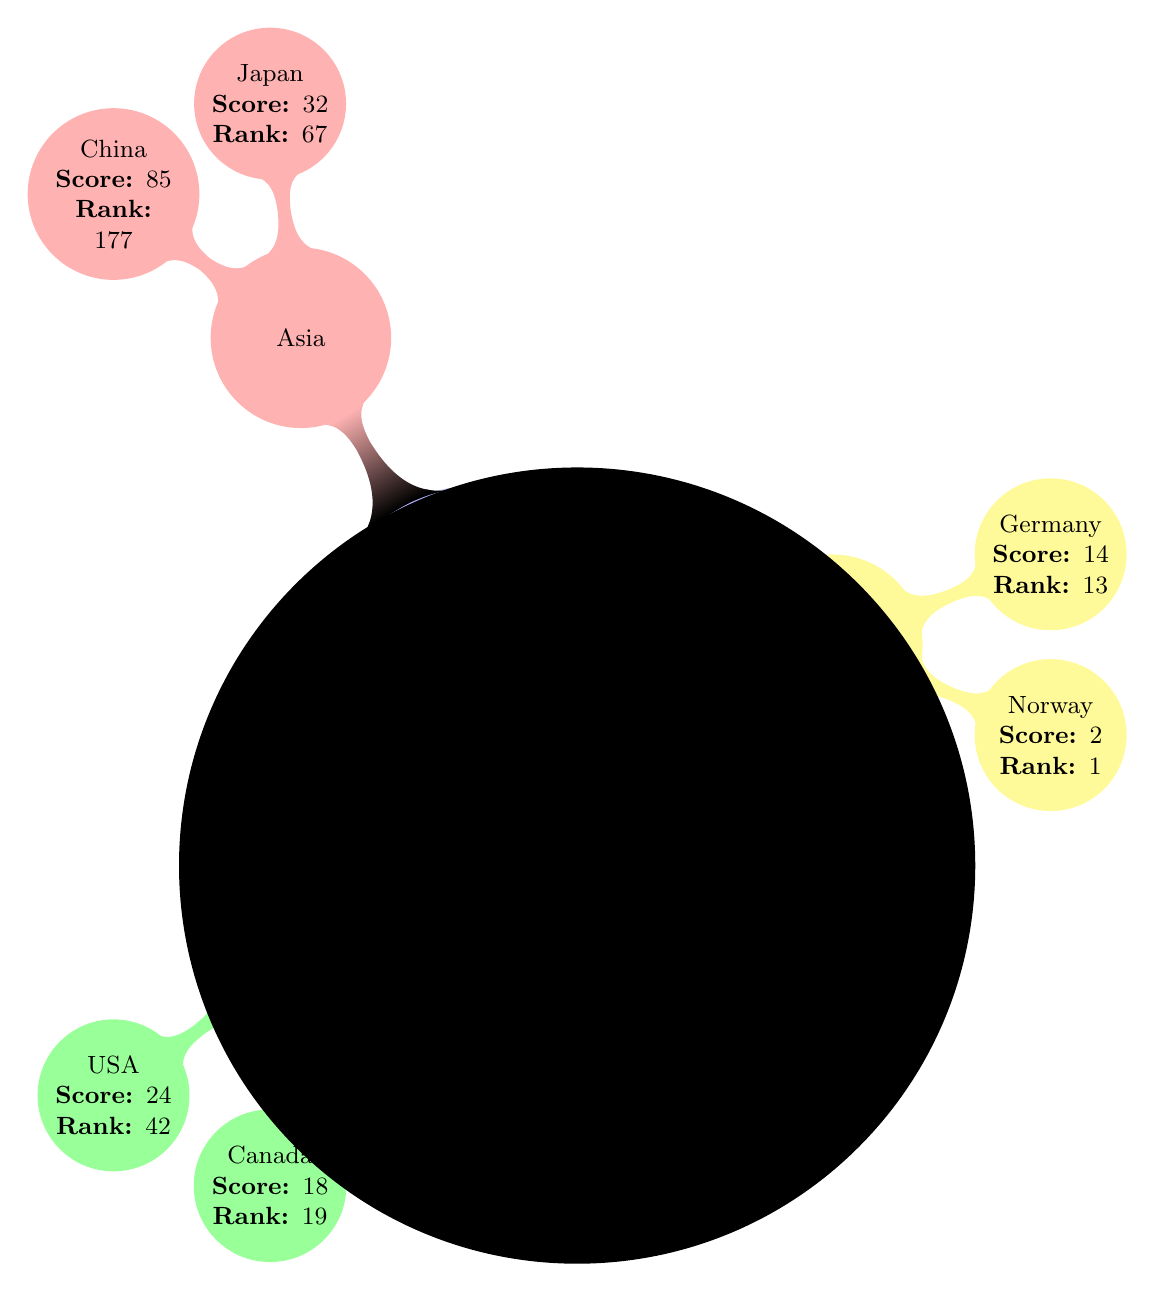What is the rank of the USA in the Global Press Freedom Index 2023? The USA has a rank of 42 as indicated next to the name in the diagram.
Answer: 42 Which country has the highest rank in Europe for press freedom? Based on the diagram, Norway is listed under Europe with a rank of 1, indicating it has the highest rank in that region for press freedom.
Answer: Norway What is the score of China in the Global Press Freedom Index 2023? The diagram shows China with a score of 85 represented next to its name, reflecting its low level of press freedom.
Answer: 85 How many countries are represented under Asia in the diagram? The diagram lists two countries under Asia: Japan and China. Therefore, the total count is two.
Answer: 2 Which country has a better press freedom score, Canada or Germany? Comparing the scores from the diagram, Canada has a score of 18 and Germany a score of 14. Since 14 is lower than 18, Germany has better press freedom.
Answer: Germany What does a lower score indicate about press freedom according to the note? The note in the diagram states that lower scores and rankings indicate better press freedom, thereby establishing that score inversely reflects press freedom quality.
Answer: Better What is the score of Japan in the Global Press Freedom Index 2023? Japan's score is listed as 32 on the diagram, indicating its level of press freedom.
Answer: 32 Which continent has the country with the best score overall? According to the diagram, Norway has the best score of 2, which is listed under Europe, making it the continent with the best score overall.
Answer: Europe How many total regions are represented in the diagram regarding the Global Press Freedom Index? The diagram categorizes the countries into three regions: North America, Europe, and Asia, leading to a total of three regions represented.
Answer: 3 